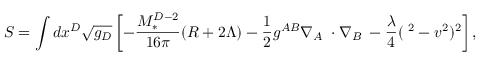Convert formula to latex. <formula><loc_0><loc_0><loc_500><loc_500>S = \int d x ^ { D } \sqrt { g _ { D } } \left [ - \frac { M _ { * } ^ { D - 2 } } { 1 6 \pi } ( R + 2 \Lambda ) - \frac { 1 } { 2 } g ^ { A B } \nabla _ { A } { \Phi } \cdot \nabla _ { B } { \Phi } - \frac { \lambda } { 4 } ( { \Phi } ^ { 2 } - v ^ { 2 } ) ^ { 2 } \right ] ,</formula> 